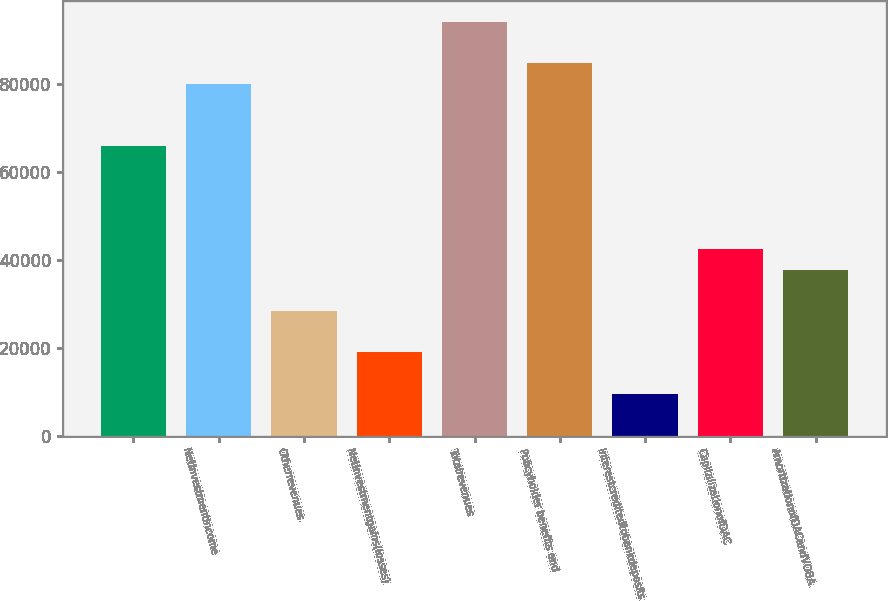Convert chart. <chart><loc_0><loc_0><loc_500><loc_500><bar_chart><ecel><fcel>Netinvestmentincome<fcel>Otherrevenues<fcel>Netinvestmentgains(losses)<fcel>Totalrevenues<fcel>Policyholder benefits and<fcel>Interestcreditedtobankdeposits<fcel>CapitalizationofDAC<fcel>AmortizationofDACandVOBA<nl><fcel>65958<fcel>80062.5<fcel>28346<fcel>18943<fcel>94167<fcel>84764<fcel>9540<fcel>42450.5<fcel>37749<nl></chart> 